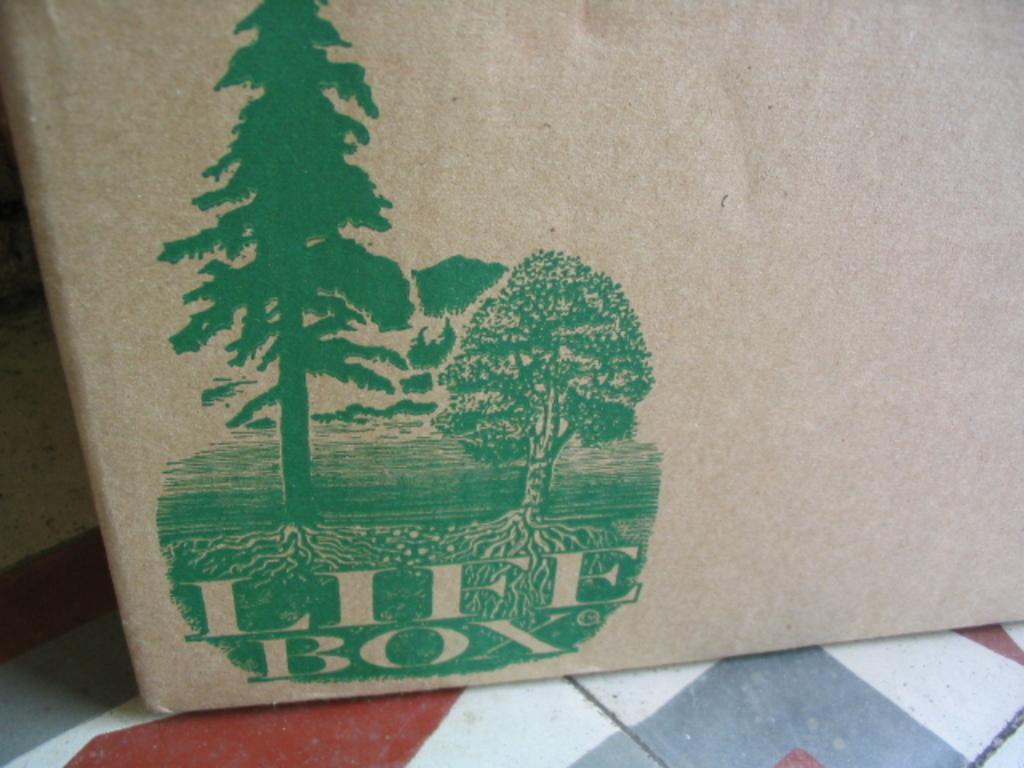<image>
Write a terse but informative summary of the picture. Art work of two trees in green with LIFE BOX written on a box. 